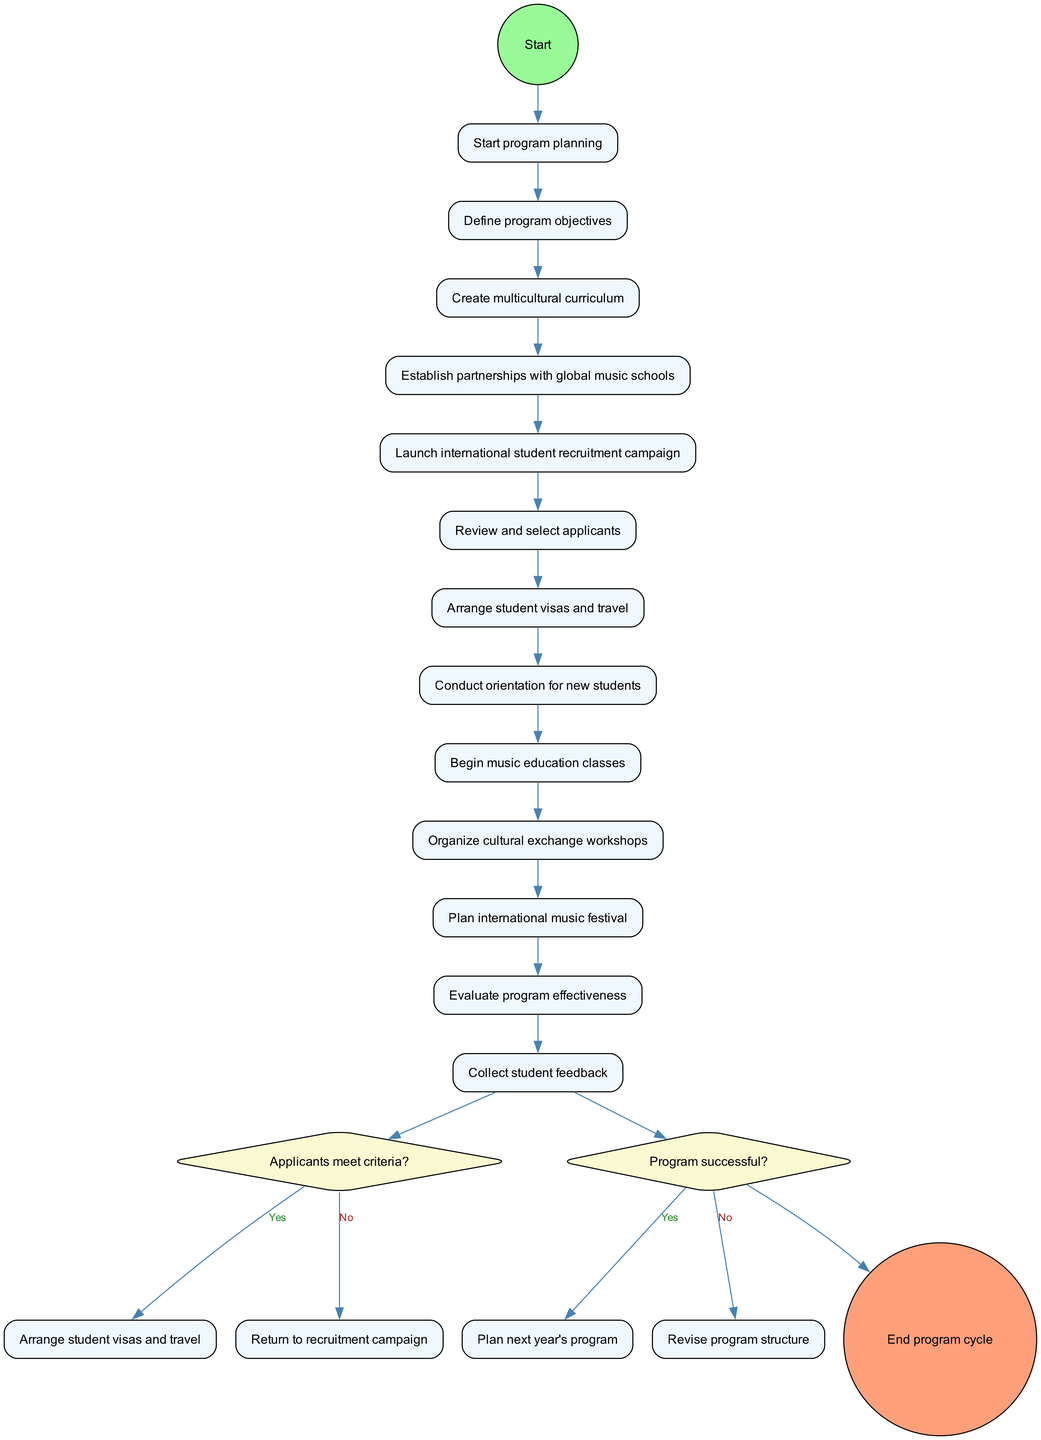What is the first activity in the program? The first activity listed in the diagram is "Define program objectives." It is the first node after the initial planning start node.
Answer: Define program objectives How many decision nodes are in the diagram? The diagram includes two decision nodes labeled with conditions, indicating points in the process where a decision is required.
Answer: 2 What happens if applicants do not meet the criteria? If applicants do not meet the criteria, the process returns to the recruitment campaign. This is shown as a flow from the decision node (that checks the criteria) to a prior activity.
Answer: Return to recruitment campaign What is the last activity before the program cycle ends? The last activity before ending the program cycle is "Collect student feedback," which directly leads to the final node indicating the end of the program.
Answer: Collect student feedback What leads to revising the program structure? Revising the program structure occurs if the program is not deemed successful, as indicated by the "no" path of the second decision node in the diagram.
Answer: Revise program structure Which activity follows after arranging student visas and travel? The activity that follows "Arrange student visas and travel" is "Conduct orientation for new students." This is a direct progression in the flow from one activity to the next.
Answer: Conduct orientation for new students What is the condition checked before arranging student visas and travel? The condition checked is "Applicants meet criteria?" This is a decision point, determining whether the process can proceed with arranging visas.
Answer: Applicants meet criteria? What is the outcome if the program is successful? If the program is successful, the outcome is to "Plan next year's program," as indicated by the "yes" decision path from the success check decision node.
Answer: Plan next year's program 